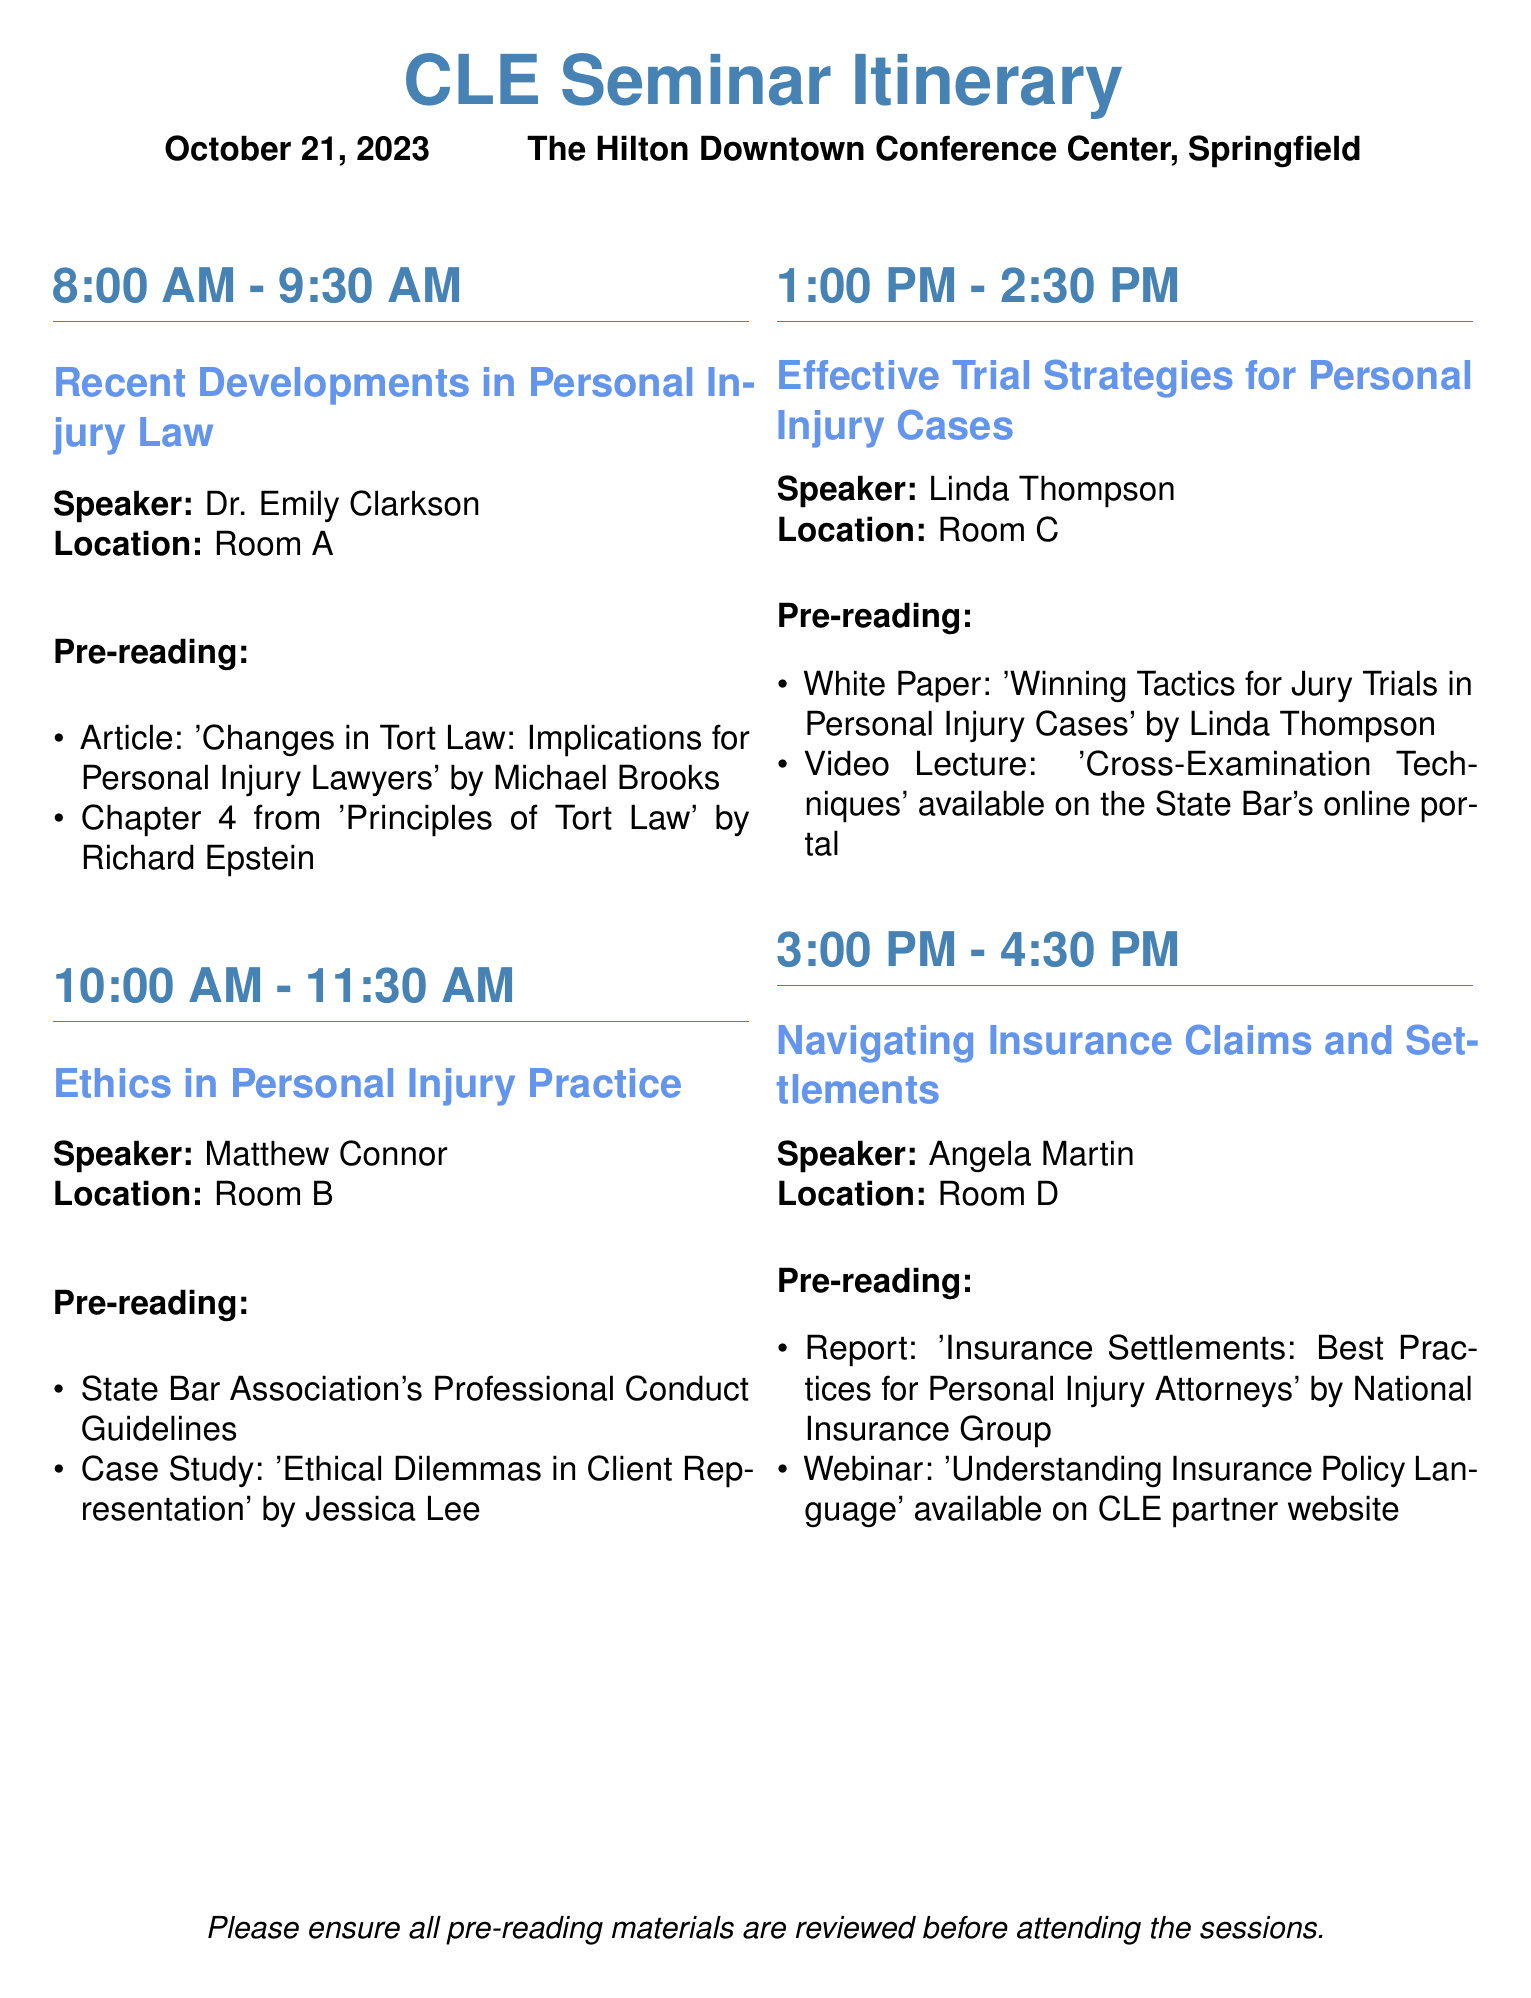What is the date of the CLE Seminar? The date is mentioned at the beginning of the document.
Answer: October 21, 2023 Who is the speaker for the session on Ethics in Personal Injury Practice? The speaker is listed under the session title within the document.
Answer: Matthew Connor What is the location of the session on Navigating Insurance Claims and Settlements? The location is specified alongside the session details.
Answer: Room D What pre-reading material is required for the Effective Trial Strategies for Personal Injury Cases session? The pre-reading items are listed in the corresponding session paragraph.
Answer: White Paper: 'Winning Tactics for Jury Trials in Personal Injury Cases' by Linda Thompson How long is the session on Recent Developments in Personal Injury Law? The duration is stated in the time block accompanying the session title.
Answer: 1.5 hours Which session speaker authored the pre-reading material "Understanding Insurance Policy Language"? The material is aligned with the speaker for that session.
Answer: Not specified in the document What color is used for the section titles in the document? The color is defined in the document's formatting section.
Answer: Header color (RGB: 70,130,180) What time does the session on Effective Trial Strategies for Personal Injury Cases start? The start time is indicated next to the session title.
Answer: 1:00 PM 